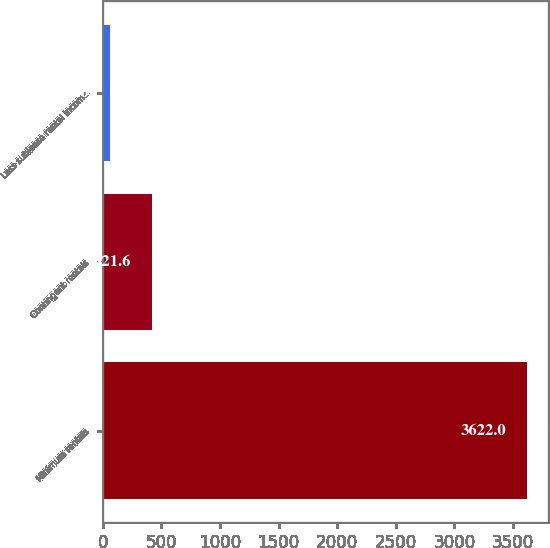Convert chart to OTSL. <chart><loc_0><loc_0><loc_500><loc_500><bar_chart><fcel>Minimum rentals<fcel>Contingent rentals<fcel>Less sublease rental income<nl><fcel>3622<fcel>421.6<fcel>66<nl></chart> 